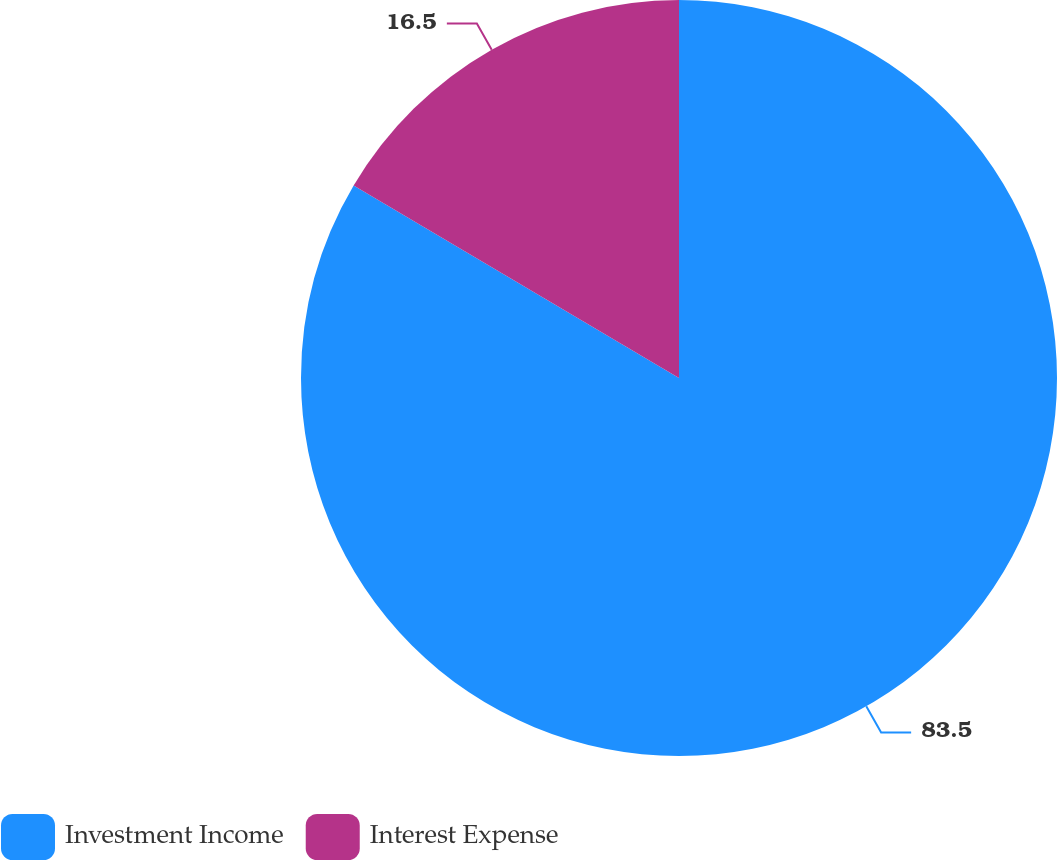Convert chart to OTSL. <chart><loc_0><loc_0><loc_500><loc_500><pie_chart><fcel>Investment Income<fcel>Interest Expense<nl><fcel>83.5%<fcel>16.5%<nl></chart> 